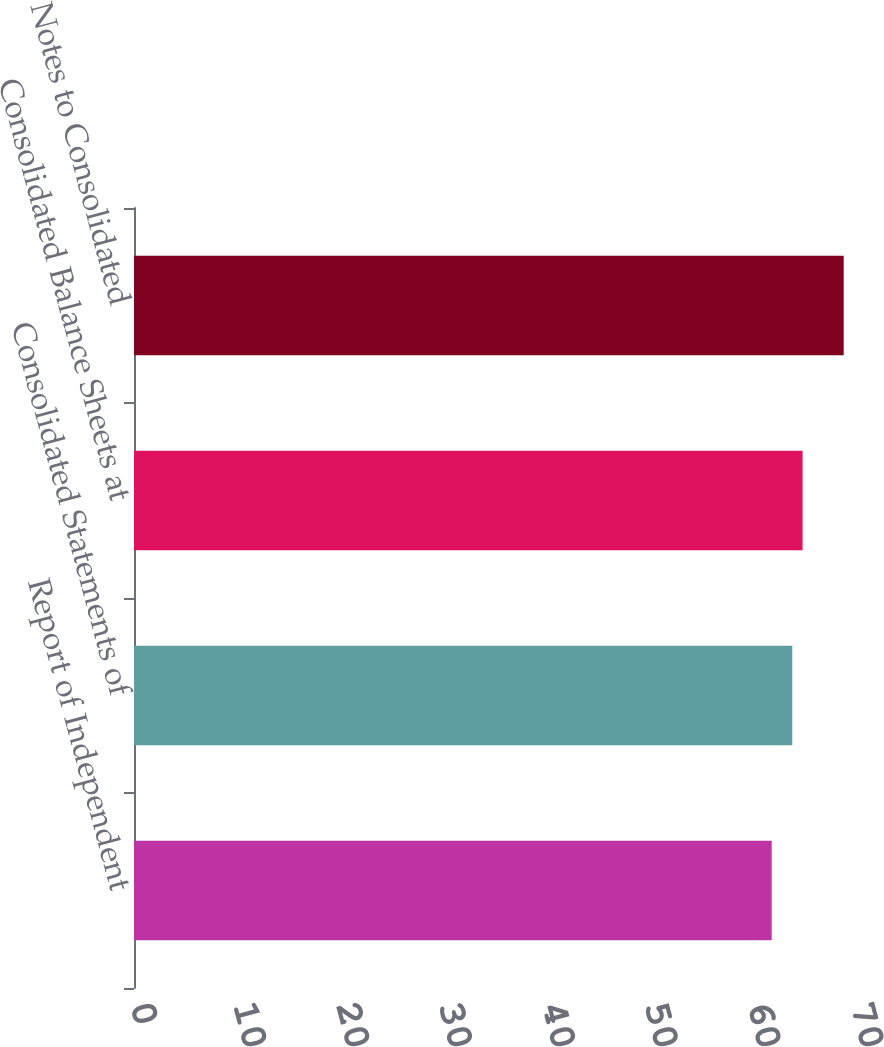Convert chart to OTSL. <chart><loc_0><loc_0><loc_500><loc_500><bar_chart><fcel>Report of Independent<fcel>Consolidated Statements of<fcel>Consolidated Balance Sheets at<fcel>Notes to Consolidated<nl><fcel>62<fcel>64<fcel>65<fcel>69<nl></chart> 